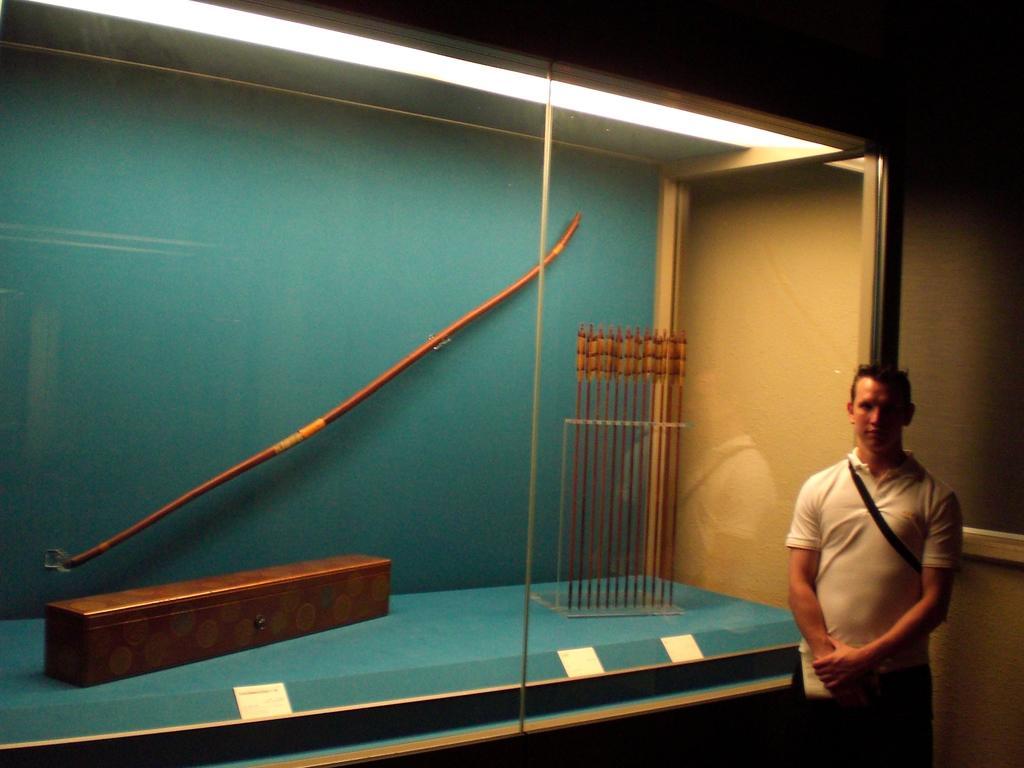Please provide a concise description of this image. In this picture there is a man towards the right corner. He is wearing a white t shirt. He is standing beside the glass. In the glass, there is a box, arrows and a stick etc. 